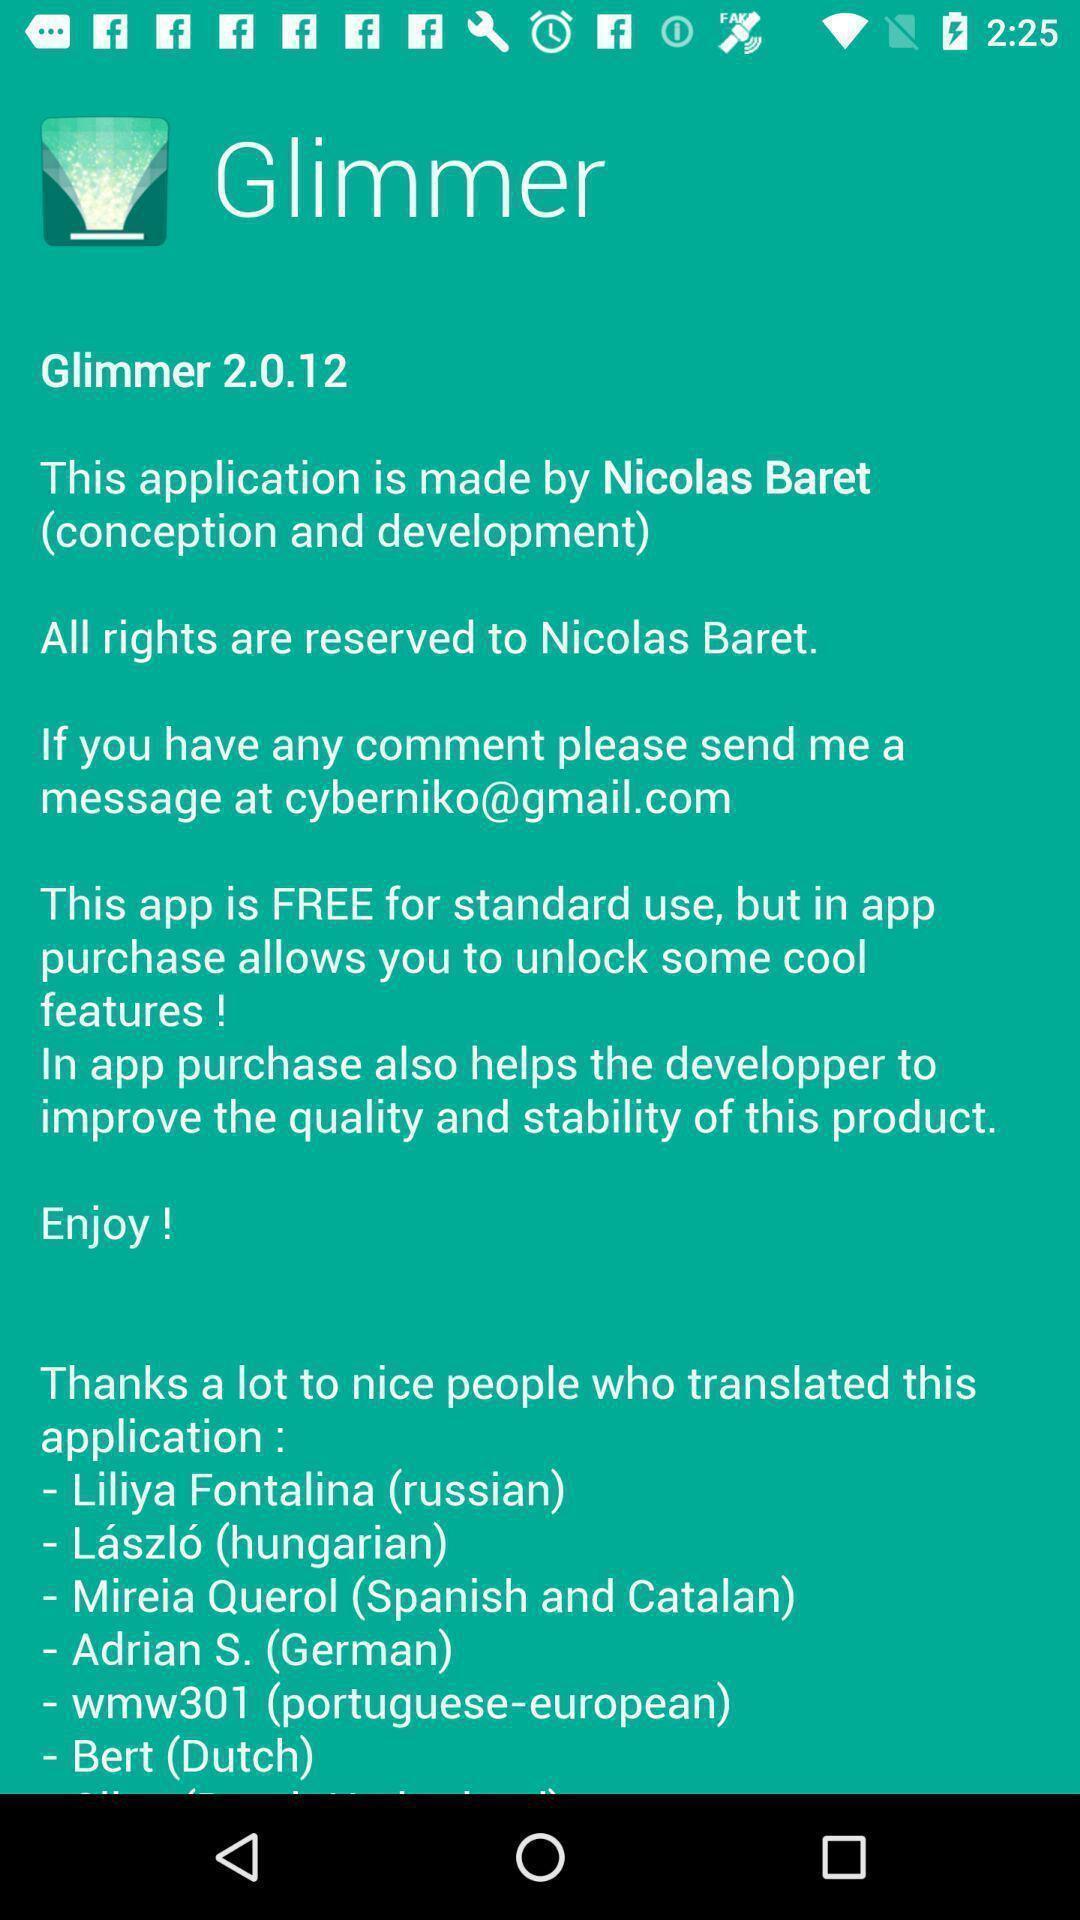Tell me what you see in this picture. Screen showing the description. 